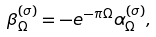Convert formula to latex. <formula><loc_0><loc_0><loc_500><loc_500>\beta _ { \Omega } ^ { ( \sigma ) } = - e ^ { - \pi \Omega } \alpha _ { \Omega } ^ { ( \sigma ) } ,</formula> 